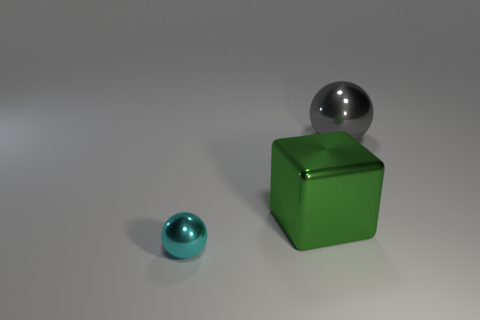There is a object left of the green metallic thing; is it the same shape as the large gray object?
Your answer should be compact. Yes. The other thing that is the same shape as the big gray thing is what color?
Your answer should be very brief. Cyan. There is another shiny object that is the same shape as the tiny object; what is its size?
Ensure brevity in your answer.  Large. What is the material of the object that is both behind the tiny cyan metal thing and in front of the big ball?
Offer a terse response. Metal. Are there any big green metallic blocks left of the gray metallic object?
Provide a short and direct response. Yes. Is the material of the tiny cyan ball the same as the large sphere?
Ensure brevity in your answer.  Yes. How many objects are gray spheres behind the small metal sphere or cyan things?
Offer a terse response. 2. Is the number of small cyan metal objects that are to the right of the gray shiny sphere the same as the number of big rubber cubes?
Give a very brief answer. Yes. The metallic object that is right of the small cyan metallic object and left of the big metal sphere is what color?
Your answer should be very brief. Green. What number of cubes are either cyan objects or green shiny things?
Your answer should be compact. 1. 